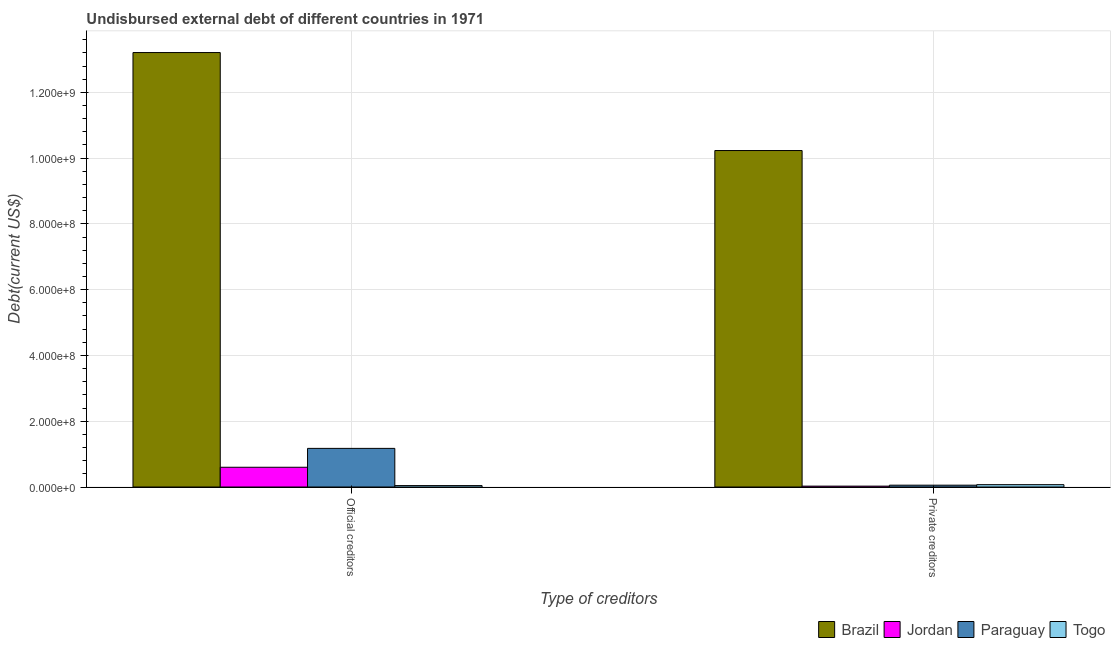What is the label of the 2nd group of bars from the left?
Give a very brief answer. Private creditors. What is the undisbursed external debt of private creditors in Brazil?
Provide a short and direct response. 1.02e+09. Across all countries, what is the maximum undisbursed external debt of private creditors?
Provide a short and direct response. 1.02e+09. Across all countries, what is the minimum undisbursed external debt of official creditors?
Make the answer very short. 4.34e+06. In which country was the undisbursed external debt of private creditors minimum?
Provide a short and direct response. Jordan. What is the total undisbursed external debt of official creditors in the graph?
Your answer should be compact. 1.50e+09. What is the difference between the undisbursed external debt of private creditors in Jordan and that in Togo?
Your answer should be compact. -4.43e+06. What is the difference between the undisbursed external debt of private creditors in Jordan and the undisbursed external debt of official creditors in Paraguay?
Provide a succinct answer. -1.15e+08. What is the average undisbursed external debt of official creditors per country?
Give a very brief answer. 3.76e+08. What is the difference between the undisbursed external debt of private creditors and undisbursed external debt of official creditors in Brazil?
Ensure brevity in your answer.  -2.98e+08. In how many countries, is the undisbursed external debt of private creditors greater than 160000000 US$?
Keep it short and to the point. 1. What is the ratio of the undisbursed external debt of official creditors in Togo to that in Brazil?
Offer a very short reply. 0. Is the undisbursed external debt of private creditors in Brazil less than that in Jordan?
Provide a succinct answer. No. What does the 3rd bar from the left in Official creditors represents?
Your response must be concise. Paraguay. What does the 2nd bar from the right in Official creditors represents?
Your response must be concise. Paraguay. How many countries are there in the graph?
Provide a short and direct response. 4. Does the graph contain any zero values?
Provide a short and direct response. No. Does the graph contain grids?
Your response must be concise. Yes. How are the legend labels stacked?
Offer a very short reply. Horizontal. What is the title of the graph?
Ensure brevity in your answer.  Undisbursed external debt of different countries in 1971. What is the label or title of the X-axis?
Offer a very short reply. Type of creditors. What is the label or title of the Y-axis?
Provide a short and direct response. Debt(current US$). What is the Debt(current US$) of Brazil in Official creditors?
Offer a terse response. 1.32e+09. What is the Debt(current US$) of Jordan in Official creditors?
Provide a succinct answer. 6.01e+07. What is the Debt(current US$) of Paraguay in Official creditors?
Ensure brevity in your answer.  1.17e+08. What is the Debt(current US$) in Togo in Official creditors?
Make the answer very short. 4.34e+06. What is the Debt(current US$) of Brazil in Private creditors?
Keep it short and to the point. 1.02e+09. What is the Debt(current US$) in Jordan in Private creditors?
Your answer should be very brief. 2.68e+06. What is the Debt(current US$) in Paraguay in Private creditors?
Your response must be concise. 5.58e+06. What is the Debt(current US$) of Togo in Private creditors?
Offer a very short reply. 7.12e+06. Across all Type of creditors, what is the maximum Debt(current US$) of Brazil?
Offer a terse response. 1.32e+09. Across all Type of creditors, what is the maximum Debt(current US$) in Jordan?
Your answer should be very brief. 6.01e+07. Across all Type of creditors, what is the maximum Debt(current US$) in Paraguay?
Give a very brief answer. 1.17e+08. Across all Type of creditors, what is the maximum Debt(current US$) in Togo?
Your answer should be compact. 7.12e+06. Across all Type of creditors, what is the minimum Debt(current US$) in Brazil?
Make the answer very short. 1.02e+09. Across all Type of creditors, what is the minimum Debt(current US$) of Jordan?
Ensure brevity in your answer.  2.68e+06. Across all Type of creditors, what is the minimum Debt(current US$) in Paraguay?
Offer a terse response. 5.58e+06. Across all Type of creditors, what is the minimum Debt(current US$) of Togo?
Your answer should be compact. 4.34e+06. What is the total Debt(current US$) in Brazil in the graph?
Provide a short and direct response. 2.34e+09. What is the total Debt(current US$) of Jordan in the graph?
Provide a succinct answer. 6.28e+07. What is the total Debt(current US$) of Paraguay in the graph?
Offer a terse response. 1.23e+08. What is the total Debt(current US$) in Togo in the graph?
Offer a terse response. 1.15e+07. What is the difference between the Debt(current US$) in Brazil in Official creditors and that in Private creditors?
Provide a succinct answer. 2.98e+08. What is the difference between the Debt(current US$) in Jordan in Official creditors and that in Private creditors?
Your answer should be very brief. 5.74e+07. What is the difference between the Debt(current US$) of Paraguay in Official creditors and that in Private creditors?
Keep it short and to the point. 1.12e+08. What is the difference between the Debt(current US$) in Togo in Official creditors and that in Private creditors?
Your answer should be very brief. -2.78e+06. What is the difference between the Debt(current US$) of Brazil in Official creditors and the Debt(current US$) of Jordan in Private creditors?
Give a very brief answer. 1.32e+09. What is the difference between the Debt(current US$) in Brazil in Official creditors and the Debt(current US$) in Paraguay in Private creditors?
Ensure brevity in your answer.  1.32e+09. What is the difference between the Debt(current US$) of Brazil in Official creditors and the Debt(current US$) of Togo in Private creditors?
Offer a terse response. 1.31e+09. What is the difference between the Debt(current US$) in Jordan in Official creditors and the Debt(current US$) in Paraguay in Private creditors?
Your response must be concise. 5.45e+07. What is the difference between the Debt(current US$) of Jordan in Official creditors and the Debt(current US$) of Togo in Private creditors?
Ensure brevity in your answer.  5.30e+07. What is the difference between the Debt(current US$) in Paraguay in Official creditors and the Debt(current US$) in Togo in Private creditors?
Offer a very short reply. 1.10e+08. What is the average Debt(current US$) of Brazil per Type of creditors?
Ensure brevity in your answer.  1.17e+09. What is the average Debt(current US$) of Jordan per Type of creditors?
Ensure brevity in your answer.  3.14e+07. What is the average Debt(current US$) in Paraguay per Type of creditors?
Your response must be concise. 6.15e+07. What is the average Debt(current US$) of Togo per Type of creditors?
Make the answer very short. 5.73e+06. What is the difference between the Debt(current US$) of Brazil and Debt(current US$) of Jordan in Official creditors?
Ensure brevity in your answer.  1.26e+09. What is the difference between the Debt(current US$) of Brazil and Debt(current US$) of Paraguay in Official creditors?
Your response must be concise. 1.20e+09. What is the difference between the Debt(current US$) of Brazil and Debt(current US$) of Togo in Official creditors?
Your answer should be very brief. 1.32e+09. What is the difference between the Debt(current US$) of Jordan and Debt(current US$) of Paraguay in Official creditors?
Your response must be concise. -5.74e+07. What is the difference between the Debt(current US$) of Jordan and Debt(current US$) of Togo in Official creditors?
Give a very brief answer. 5.57e+07. What is the difference between the Debt(current US$) in Paraguay and Debt(current US$) in Togo in Official creditors?
Provide a short and direct response. 1.13e+08. What is the difference between the Debt(current US$) in Brazil and Debt(current US$) in Jordan in Private creditors?
Make the answer very short. 1.02e+09. What is the difference between the Debt(current US$) in Brazil and Debt(current US$) in Paraguay in Private creditors?
Provide a short and direct response. 1.02e+09. What is the difference between the Debt(current US$) of Brazil and Debt(current US$) of Togo in Private creditors?
Keep it short and to the point. 1.02e+09. What is the difference between the Debt(current US$) in Jordan and Debt(current US$) in Paraguay in Private creditors?
Keep it short and to the point. -2.89e+06. What is the difference between the Debt(current US$) of Jordan and Debt(current US$) of Togo in Private creditors?
Offer a terse response. -4.43e+06. What is the difference between the Debt(current US$) of Paraguay and Debt(current US$) of Togo in Private creditors?
Keep it short and to the point. -1.54e+06. What is the ratio of the Debt(current US$) in Brazil in Official creditors to that in Private creditors?
Your answer should be compact. 1.29. What is the ratio of the Debt(current US$) of Jordan in Official creditors to that in Private creditors?
Provide a short and direct response. 22.4. What is the ratio of the Debt(current US$) in Paraguay in Official creditors to that in Private creditors?
Make the answer very short. 21.07. What is the ratio of the Debt(current US$) of Togo in Official creditors to that in Private creditors?
Your answer should be very brief. 0.61. What is the difference between the highest and the second highest Debt(current US$) in Brazil?
Provide a short and direct response. 2.98e+08. What is the difference between the highest and the second highest Debt(current US$) in Jordan?
Give a very brief answer. 5.74e+07. What is the difference between the highest and the second highest Debt(current US$) of Paraguay?
Give a very brief answer. 1.12e+08. What is the difference between the highest and the second highest Debt(current US$) in Togo?
Offer a very short reply. 2.78e+06. What is the difference between the highest and the lowest Debt(current US$) of Brazil?
Your response must be concise. 2.98e+08. What is the difference between the highest and the lowest Debt(current US$) in Jordan?
Make the answer very short. 5.74e+07. What is the difference between the highest and the lowest Debt(current US$) in Paraguay?
Your answer should be compact. 1.12e+08. What is the difference between the highest and the lowest Debt(current US$) in Togo?
Give a very brief answer. 2.78e+06. 